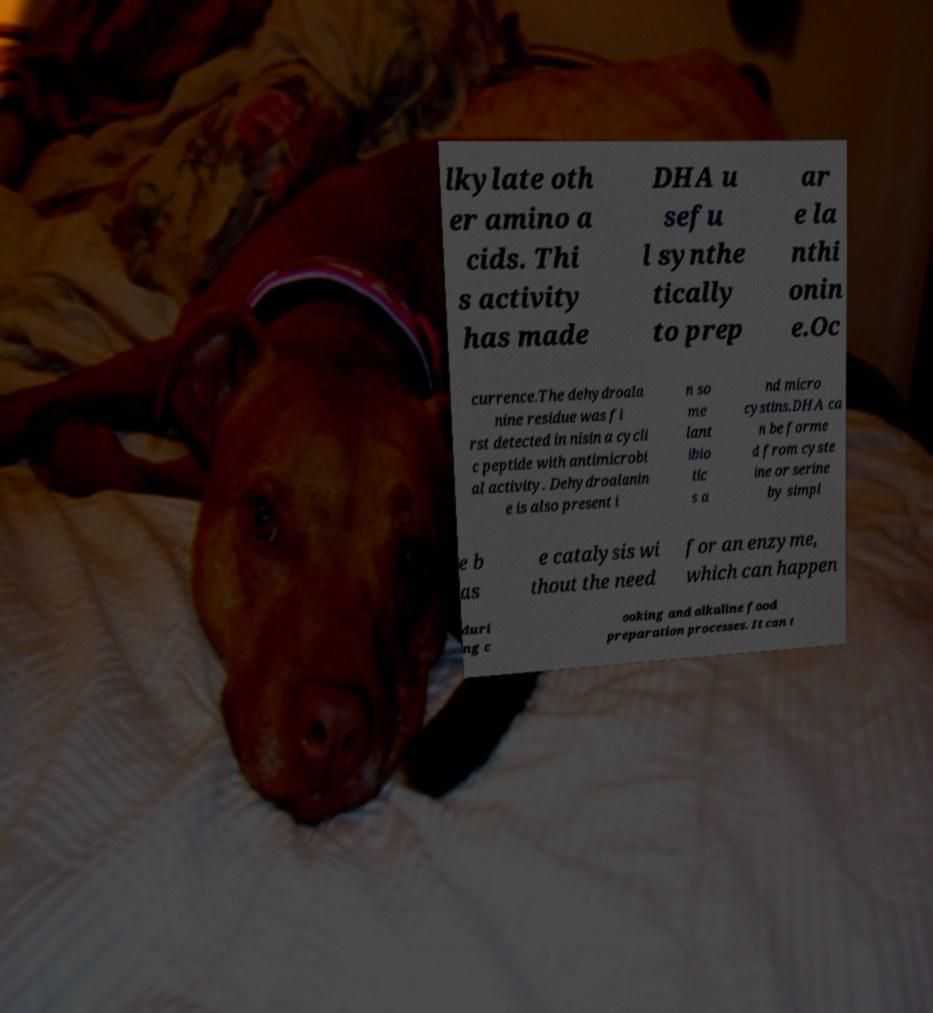Can you read and provide the text displayed in the image?This photo seems to have some interesting text. Can you extract and type it out for me? lkylate oth er amino a cids. Thi s activity has made DHA u sefu l synthe tically to prep ar e la nthi onin e.Oc currence.The dehydroala nine residue was fi rst detected in nisin a cycli c peptide with antimicrobi al activity. Dehydroalanin e is also present i n so me lant ibio tic s a nd micro cystins.DHA ca n be forme d from cyste ine or serine by simpl e b as e catalysis wi thout the need for an enzyme, which can happen duri ng c ooking and alkaline food preparation processes. It can t 